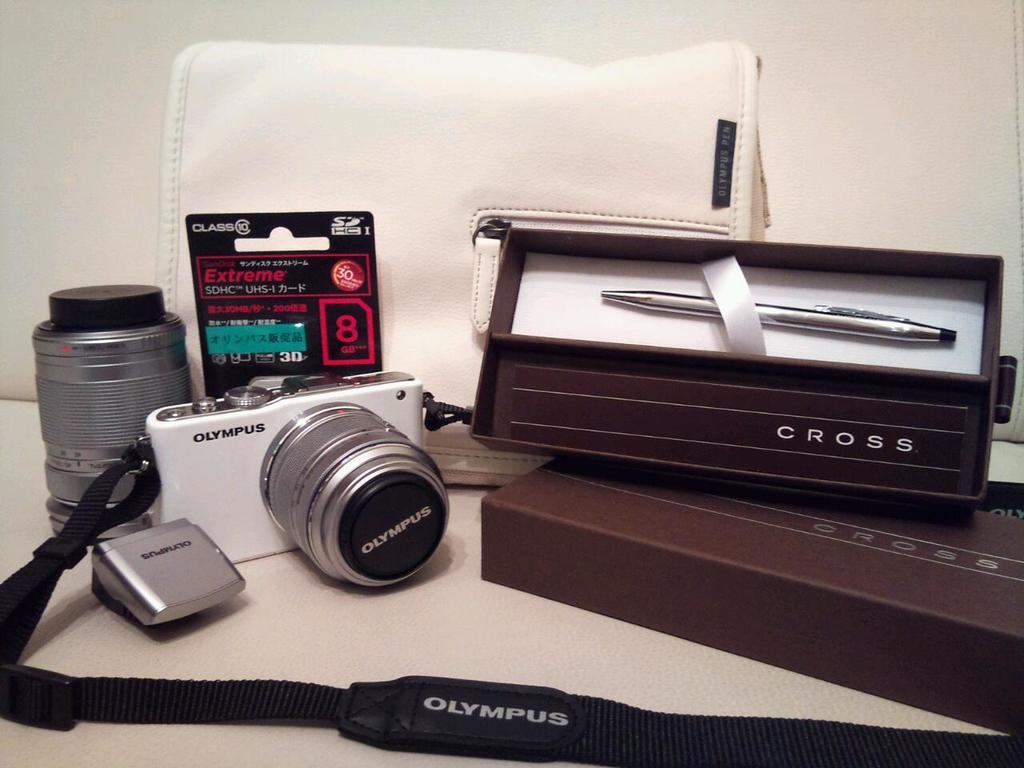What is the main object in the image? There is a camera with a strap in the image. What can be seen on the camera strap? Something is written on the camera strap. What is inside the box in the image? There is a pen inside the box in the image. What type of bag is present in the image? There is a white bag in the image. What is on a surface in the image? There is a bottle on a surface in the image. What is visible in the background of the image? There is a wall in the background of the image. What type of nerve can be seen in the image? There is no nerve present in the image. Is there a mask visible in the image? There is no mask present in the image. 